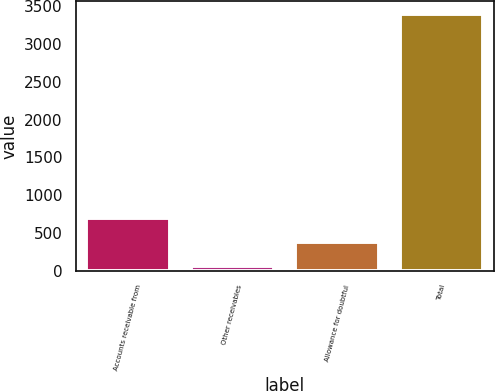<chart> <loc_0><loc_0><loc_500><loc_500><bar_chart><fcel>Accounts receivable from<fcel>Other receivables<fcel>Allowance for doubtful<fcel>Total<nl><fcel>697.8<fcel>59<fcel>378.4<fcel>3395.4<nl></chart> 